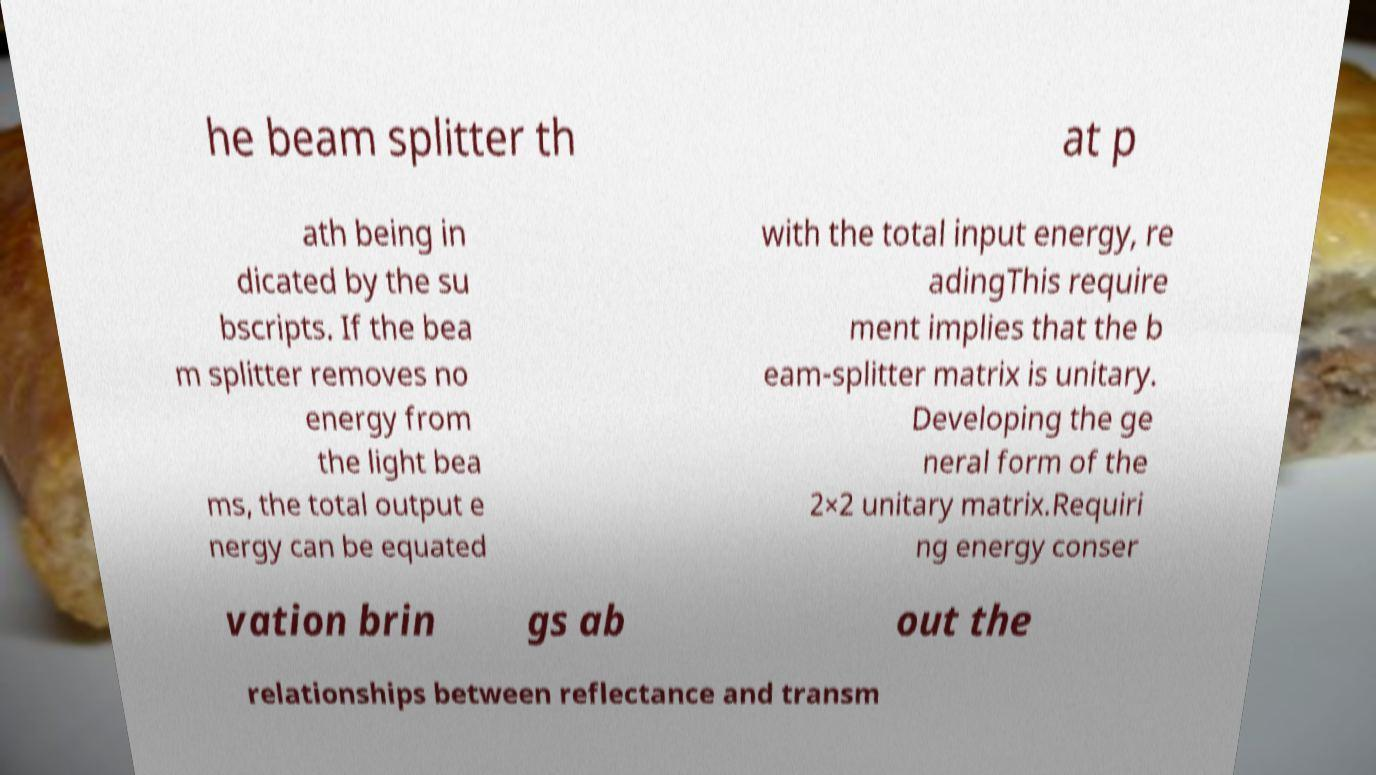Could you assist in decoding the text presented in this image and type it out clearly? he beam splitter th at p ath being in dicated by the su bscripts. If the bea m splitter removes no energy from the light bea ms, the total output e nergy can be equated with the total input energy, re adingThis require ment implies that the b eam-splitter matrix is unitary. Developing the ge neral form of the 2×2 unitary matrix.Requiri ng energy conser vation brin gs ab out the relationships between reflectance and transm 